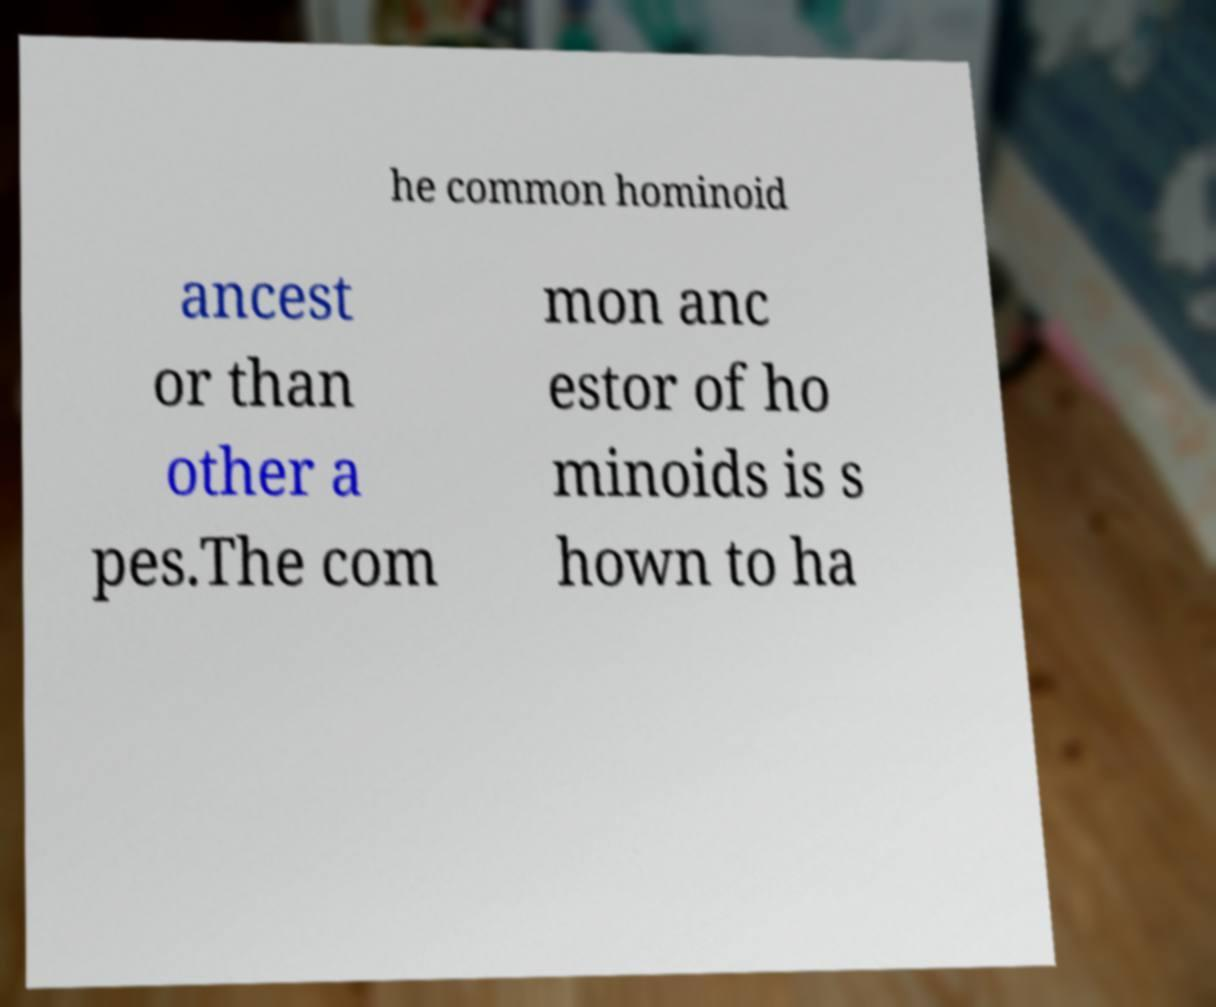For documentation purposes, I need the text within this image transcribed. Could you provide that? he common hominoid ancest or than other a pes.The com mon anc estor of ho minoids is s hown to ha 